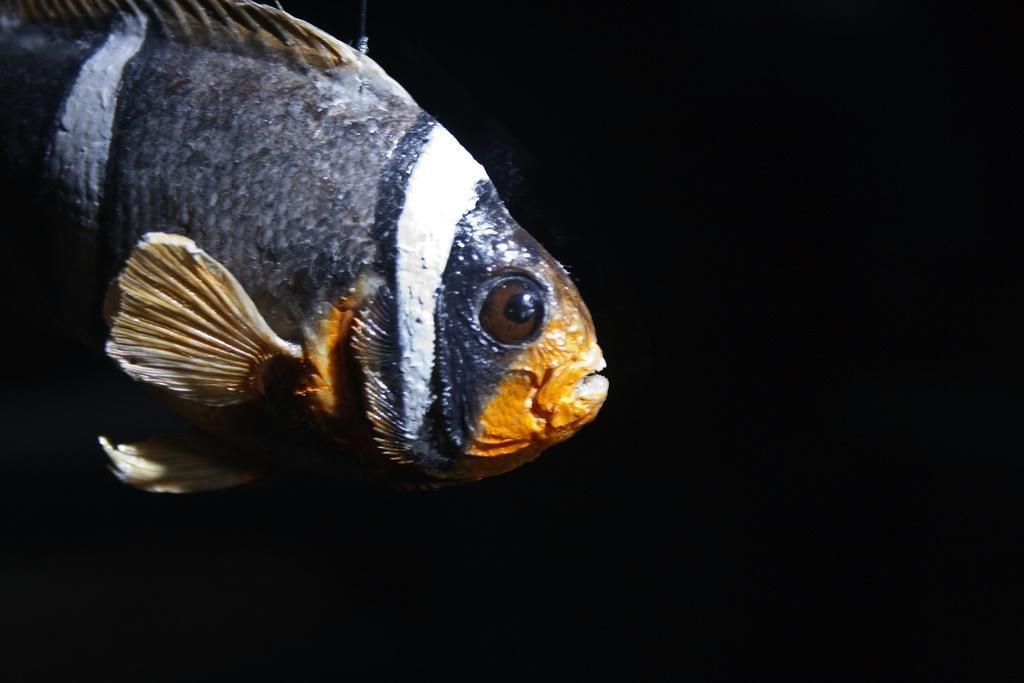Describe this image in one or two sentences. In this picture I can see there is a fish and there is a yellow color mouth and it has fins, scales and the backdrop is dark. 